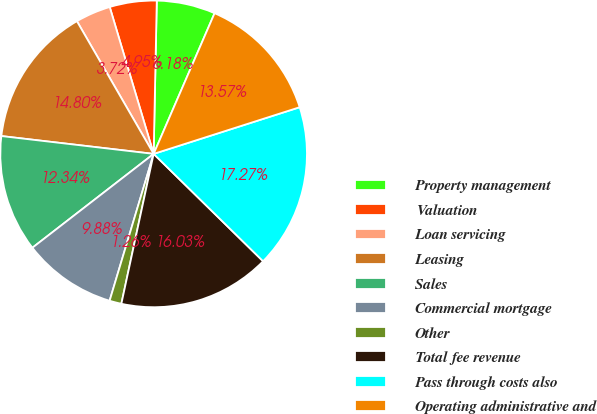Convert chart to OTSL. <chart><loc_0><loc_0><loc_500><loc_500><pie_chart><fcel>Property management<fcel>Valuation<fcel>Loan servicing<fcel>Leasing<fcel>Sales<fcel>Commercial mortgage<fcel>Other<fcel>Total fee revenue<fcel>Pass through costs also<fcel>Operating administrative and<nl><fcel>6.18%<fcel>4.95%<fcel>3.72%<fcel>14.8%<fcel>12.34%<fcel>9.88%<fcel>1.26%<fcel>16.03%<fcel>17.27%<fcel>13.57%<nl></chart> 